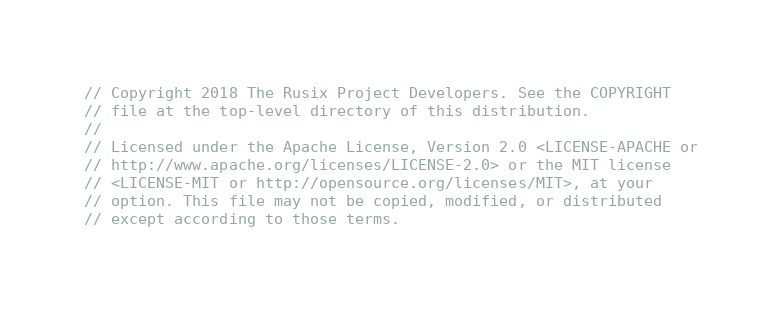Convert code to text. <code><loc_0><loc_0><loc_500><loc_500><_Rust_>// Copyright 2018 The Rusix Project Developers. See the COPYRIGHT
// file at the top-level directory of this distribution.
//
// Licensed under the Apache License, Version 2.0 <LICENSE-APACHE or
// http://www.apache.org/licenses/LICENSE-2.0> or the MIT license
// <LICENSE-MIT or http://opensource.org/licenses/MIT>, at your
// option. This file may not be copied, modified, or distributed
// except according to those terms.
</code> 